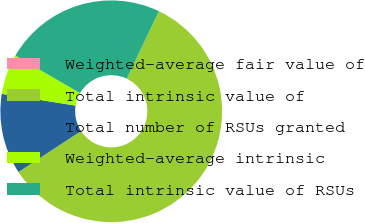Convert chart. <chart><loc_0><loc_0><loc_500><loc_500><pie_chart><fcel>Weighted-average fair value of<fcel>Total intrinsic value of<fcel>Total number of RSUs granted<fcel>Weighted-average intrinsic<fcel>Total intrinsic value of RSUs<nl><fcel>0.0%<fcel>58.7%<fcel>11.74%<fcel>5.87%<fcel>23.69%<nl></chart> 